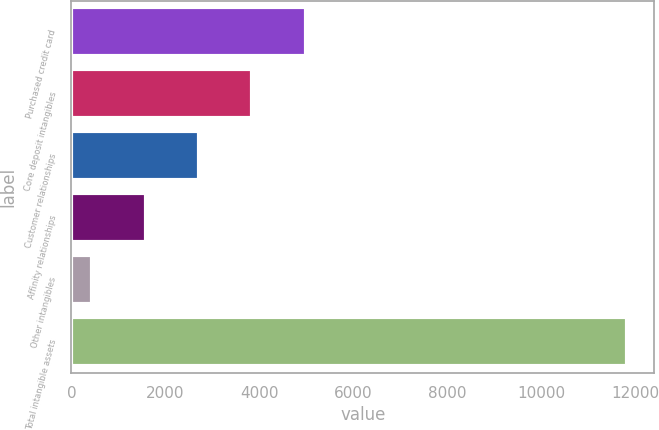Convert chart. <chart><loc_0><loc_0><loc_500><loc_500><bar_chart><fcel>Purchased credit card<fcel>Core deposit intangibles<fcel>Customer relationships<fcel>Affinity relationships<fcel>Other intangibles<fcel>Total intangible assets<nl><fcel>4993.8<fcel>3855.6<fcel>2717.4<fcel>1579.2<fcel>441<fcel>11823<nl></chart> 